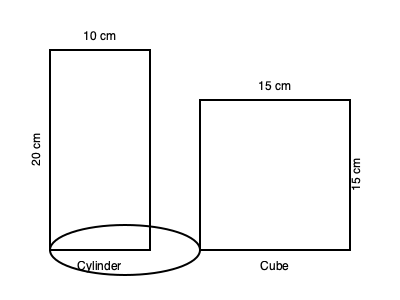As a DIY enthusiast, you're organizing your craft supplies. You have two containers: a cylindrical jar and a cubic box. The cylindrical jar has a diameter of 10 cm and a height of 20 cm, while the cubic box has sides of 15 cm. How much more volume (in cubic centimeters) can the cubic box hold compared to the cylindrical jar? To solve this problem, we need to calculate the volumes of both containers and then find the difference.

1. Volume of the cylindrical jar:
   - Formula: $V_{cylinder} = \pi r^2 h$
   - Radius (r) = diameter / 2 = 10 cm / 2 = 5 cm
   - Height (h) = 20 cm
   - $V_{cylinder} = \pi \times 5^2 \times 20 = 500\pi \approx 1570.80$ cm³

2. Volume of the cubic box:
   - Formula: $V_{cube} = s^3$, where s is the length of a side
   - Side length = 15 cm
   - $V_{cube} = 15^3 = 3375$ cm³

3. Difference in volume:
   $V_{difference} = V_{cube} - V_{cylinder}$
   $V_{difference} = 3375 - 500\pi \approx 3375 - 1570.80 = 1804.20$ cm³

Therefore, the cubic box can hold approximately 1804.20 cm³ more than the cylindrical jar.
Answer: 1804.20 cm³ 